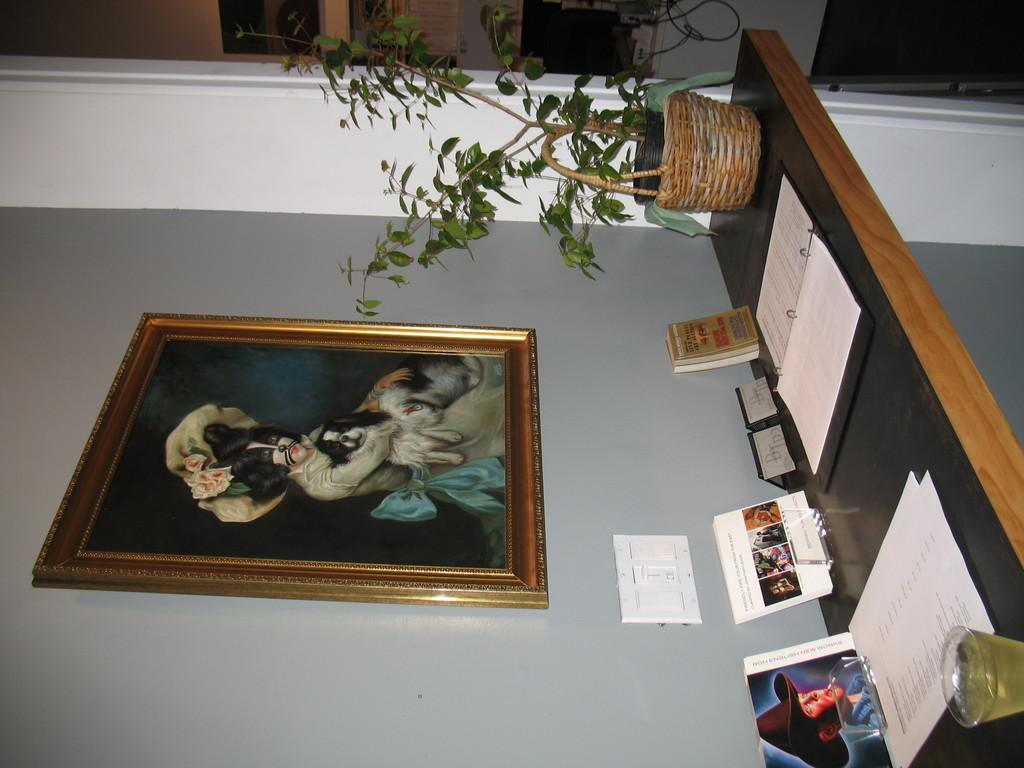What is located on the right side of the image? There is a table on the right side of the image. What items can be seen on the table? There are books, a plant pot, and a glass on the table. What is hanging on the wall above the table? There is a painting on the wall above the table. What type of juice is being served in the glass on the table? There is no juice present in the image; the glass on the table is empty. 